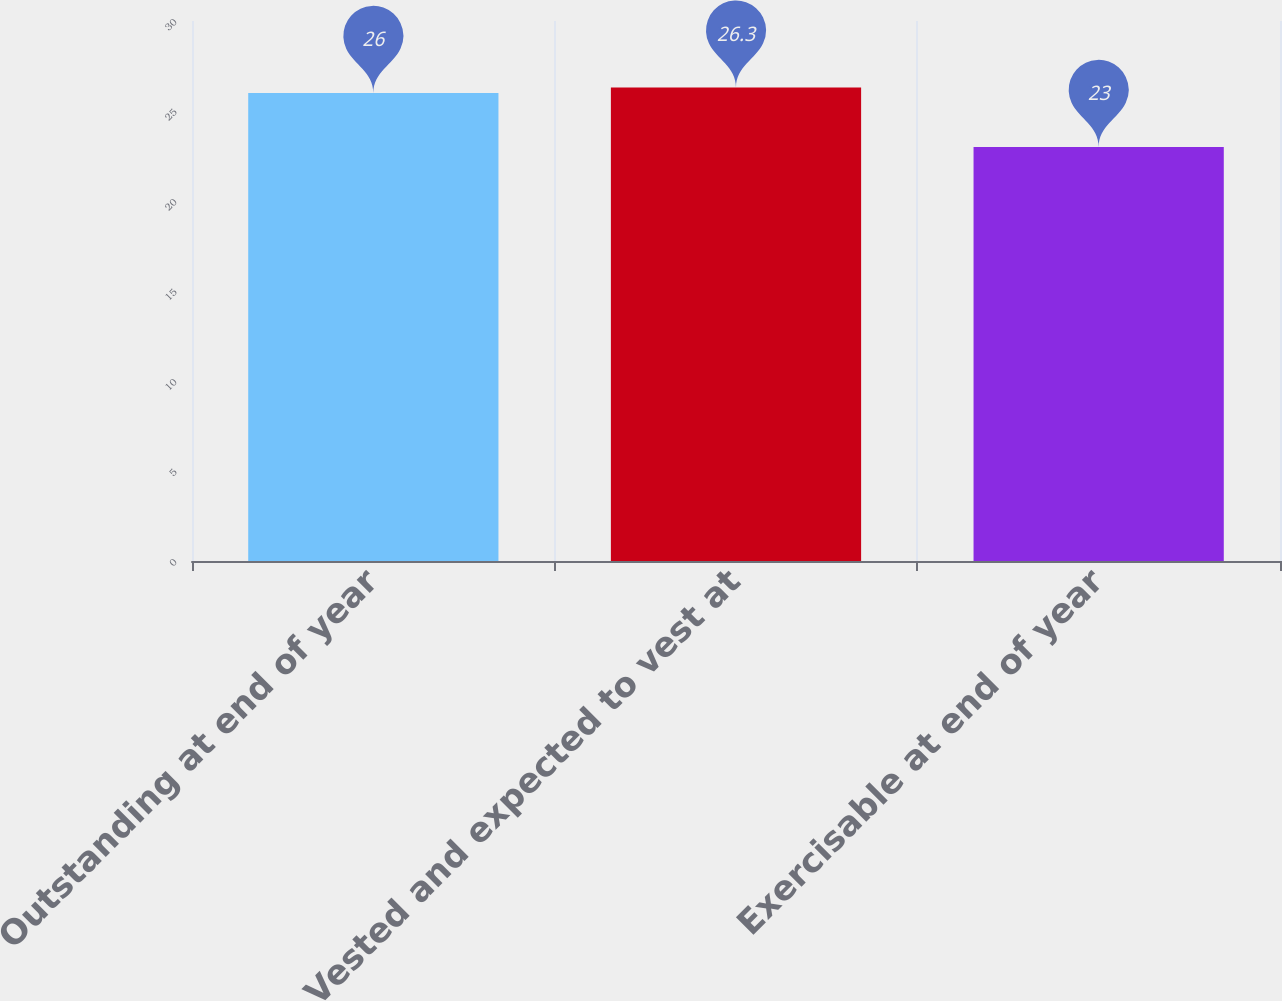Convert chart to OTSL. <chart><loc_0><loc_0><loc_500><loc_500><bar_chart><fcel>Outstanding at end of year<fcel>Vested and expected to vest at<fcel>Exercisable at end of year<nl><fcel>26<fcel>26.3<fcel>23<nl></chart> 